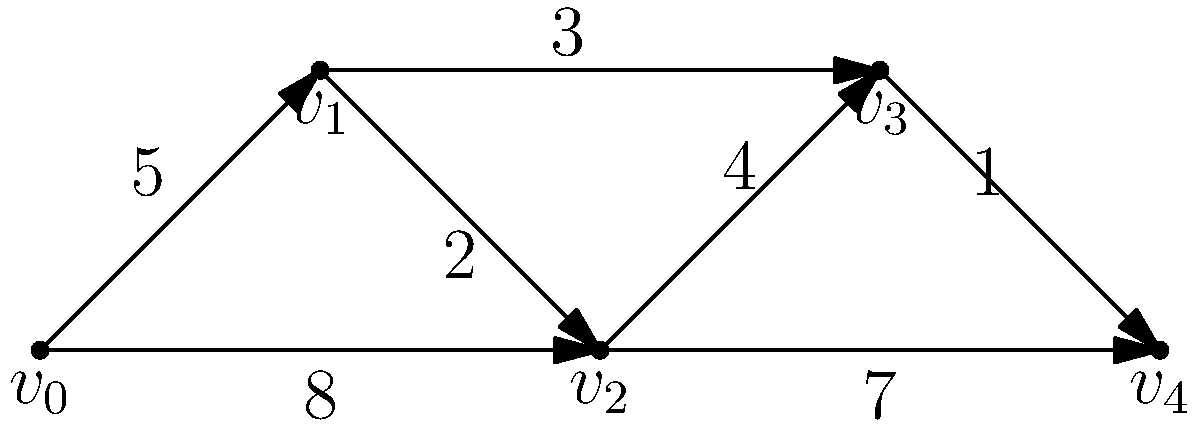Consider the directed graph representing possible player movements on a football field. Vertices represent key positions, and edge weights indicate the time (in seconds) for a player to move between positions. What is the minimum time required for a player to move from position $v_0$ to position $v_4$, and what is the optimal path? To find the minimum time and optimal path from $v_0$ to $v_4$, we'll use Dijkstra's algorithm:

1) Initialize distances: $d(v_0) = 0$, all others $\infty$
2) Set $S = \{\}$ (visited vertices)
3) While $v_4 \notin S$:
   a) Choose $v \notin S$ with minimum $d(v)$
   b) Add $v$ to $S$
   c) Update distances to neighbors of $v$

Step-by-step execution:
1) $S = \{\}$, $d(v_0) = 0$, others $\infty$
2) Choose $v_0$:
   $S = \{v_0\}$
   Update: $d(v_1) = 5$, $d(v_2) = 8$
3) Choose $v_1$:
   $S = \{v_0, v_1\}$
   Update: $d(v_2) = \min(8, 5+2) = 7$, $d(v_3) = 5+3 = 8$
4) Choose $v_2$:
   $S = \{v_0, v_1, v_2\}$
   Update: $d(v_3) = \min(8, 7+4) = 8$, $d(v_4) = 7+7 = 14$
5) Choose $v_3$:
   $S = \{v_0, v_1, v_2, v_3\}$
   Update: $d(v_4) = \min(14, 8+1) = 9$
6) Choose $v_4$: Algorithm terminates

The minimum time is 9 seconds, and the optimal path is $v_0 \rightarrow v_1 \rightarrow v_3 \rightarrow v_4$.
Answer: 9 seconds; $v_0 \rightarrow v_1 \rightarrow v_3 \rightarrow v_4$ 